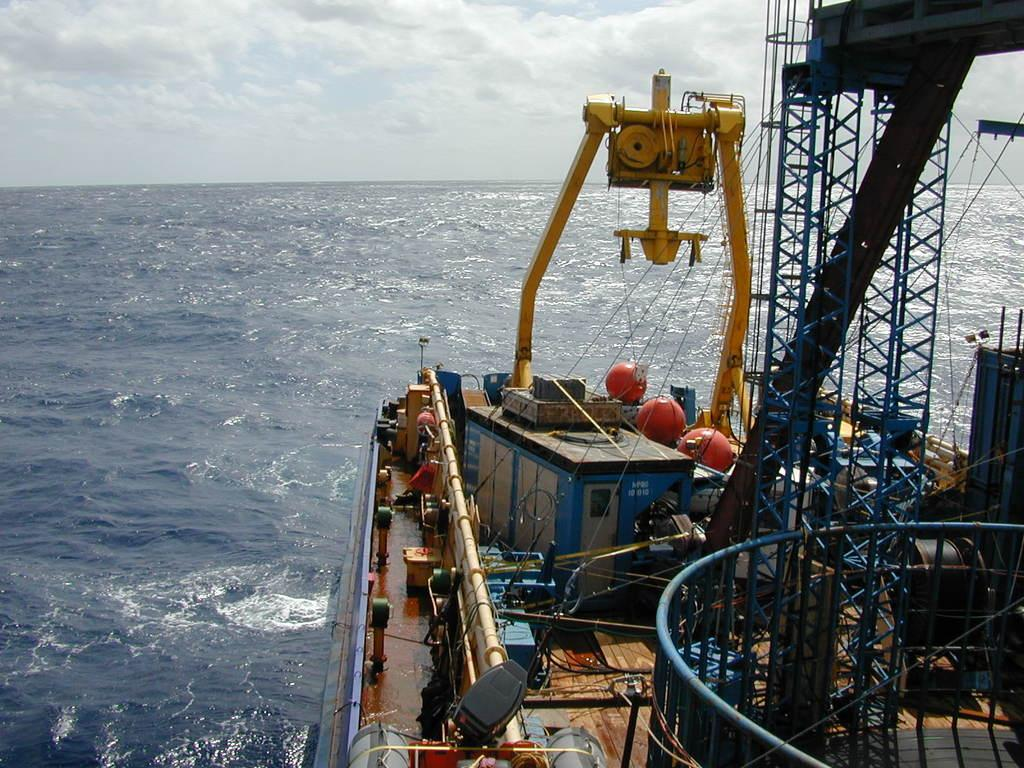What type of structure is visible in the water in the image? The image contains a deck of a ship in the water. What can be seen on the deck of the ship? There is a container and a mechanical machine on the deck. Are there any additional structures on the deck? Yes, metal scaffolding structures are present on the deck. What is visible in the sky in the image? There are clouds in the sky. How many brothers are depicted on the deck of the ship in the image? There are no people, let alone brothers, depicted on the deck of the ship in the image. 